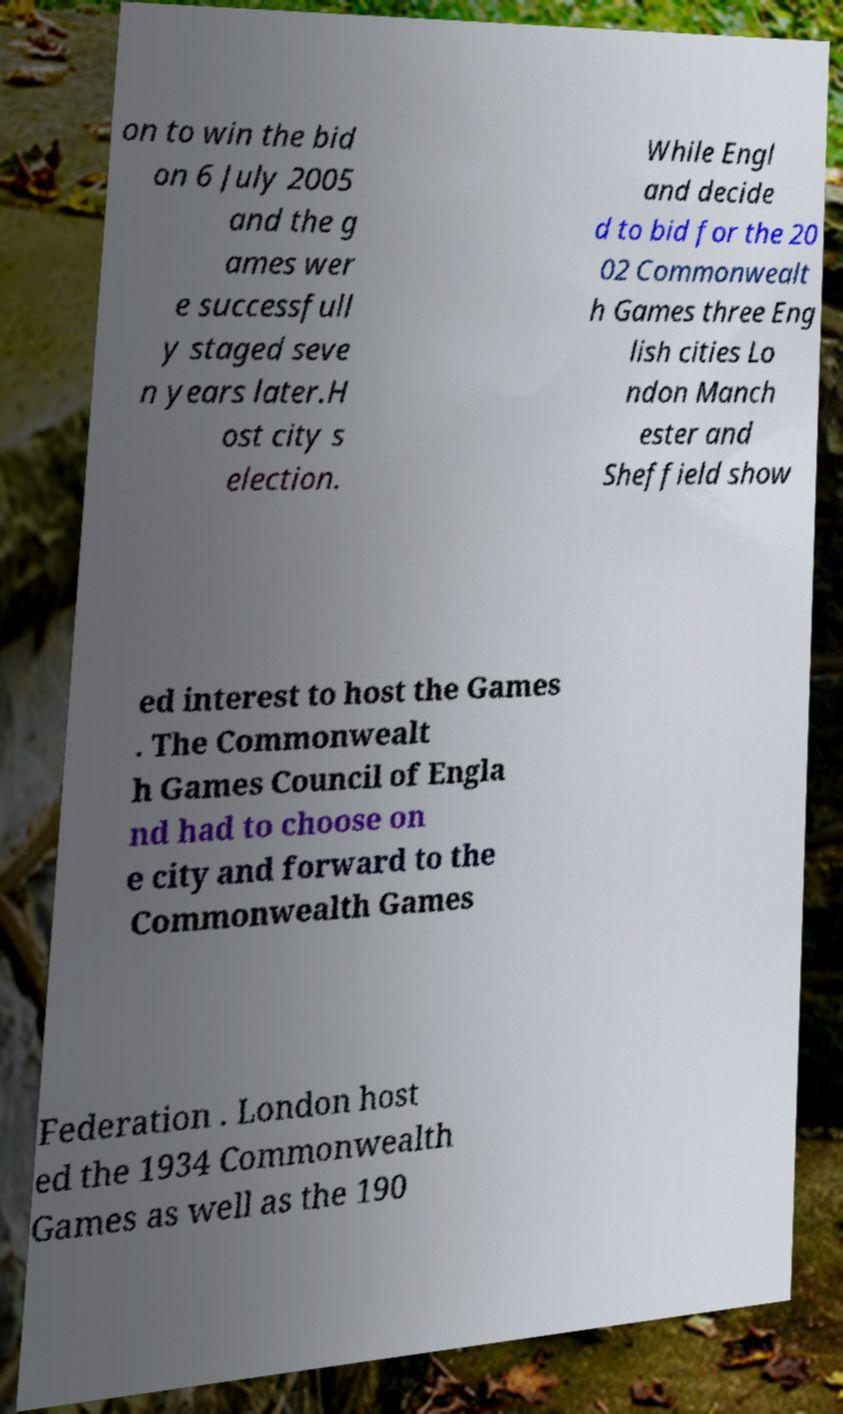For documentation purposes, I need the text within this image transcribed. Could you provide that? on to win the bid on 6 July 2005 and the g ames wer e successfull y staged seve n years later.H ost city s election. While Engl and decide d to bid for the 20 02 Commonwealt h Games three Eng lish cities Lo ndon Manch ester and Sheffield show ed interest to host the Games . The Commonwealt h Games Council of Engla nd had to choose on e city and forward to the Commonwealth Games Federation . London host ed the 1934 Commonwealth Games as well as the 190 